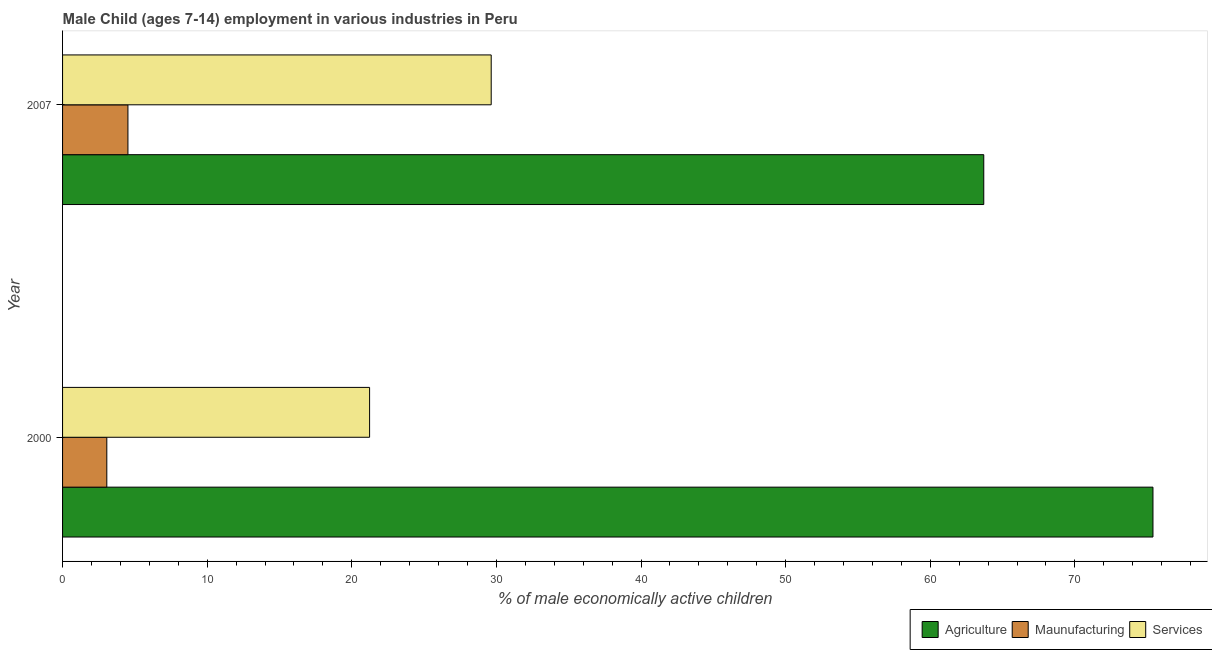How many different coloured bars are there?
Your response must be concise. 3. How many groups of bars are there?
Give a very brief answer. 2. Are the number of bars per tick equal to the number of legend labels?
Your answer should be compact. Yes. How many bars are there on the 2nd tick from the bottom?
Your response must be concise. 3. In how many cases, is the number of bars for a given year not equal to the number of legend labels?
Keep it short and to the point. 0. What is the percentage of economically active children in services in 2000?
Make the answer very short. 21.23. Across all years, what is the maximum percentage of economically active children in manufacturing?
Give a very brief answer. 4.52. Across all years, what is the minimum percentage of economically active children in services?
Offer a very short reply. 21.23. In which year was the percentage of economically active children in agriculture maximum?
Provide a short and direct response. 2000. What is the total percentage of economically active children in manufacturing in the graph?
Keep it short and to the point. 7.58. What is the difference between the percentage of economically active children in agriculture in 2000 and that in 2007?
Provide a short and direct response. 11.7. What is the difference between the percentage of economically active children in services in 2000 and the percentage of economically active children in agriculture in 2007?
Give a very brief answer. -42.47. What is the average percentage of economically active children in agriculture per year?
Offer a terse response. 69.55. In the year 2000, what is the difference between the percentage of economically active children in agriculture and percentage of economically active children in services?
Your response must be concise. 54.17. In how many years, is the percentage of economically active children in agriculture greater than 16 %?
Your response must be concise. 2. What is the ratio of the percentage of economically active children in agriculture in 2000 to that in 2007?
Keep it short and to the point. 1.18. Is the percentage of economically active children in services in 2000 less than that in 2007?
Provide a succinct answer. Yes. In how many years, is the percentage of economically active children in manufacturing greater than the average percentage of economically active children in manufacturing taken over all years?
Your answer should be very brief. 1. What does the 3rd bar from the top in 2000 represents?
Your answer should be compact. Agriculture. What does the 3rd bar from the bottom in 2007 represents?
Ensure brevity in your answer.  Services. Where does the legend appear in the graph?
Offer a very short reply. Bottom right. How are the legend labels stacked?
Offer a very short reply. Horizontal. What is the title of the graph?
Offer a very short reply. Male Child (ages 7-14) employment in various industries in Peru. What is the label or title of the X-axis?
Keep it short and to the point. % of male economically active children. What is the label or title of the Y-axis?
Your answer should be compact. Year. What is the % of male economically active children in Agriculture in 2000?
Your response must be concise. 75.4. What is the % of male economically active children of Maunufacturing in 2000?
Keep it short and to the point. 3.06. What is the % of male economically active children of Services in 2000?
Give a very brief answer. 21.23. What is the % of male economically active children of Agriculture in 2007?
Keep it short and to the point. 63.7. What is the % of male economically active children in Maunufacturing in 2007?
Offer a very short reply. 4.52. What is the % of male economically active children in Services in 2007?
Offer a very short reply. 29.64. Across all years, what is the maximum % of male economically active children in Agriculture?
Your answer should be very brief. 75.4. Across all years, what is the maximum % of male economically active children in Maunufacturing?
Provide a short and direct response. 4.52. Across all years, what is the maximum % of male economically active children of Services?
Offer a terse response. 29.64. Across all years, what is the minimum % of male economically active children in Agriculture?
Keep it short and to the point. 63.7. Across all years, what is the minimum % of male economically active children in Maunufacturing?
Keep it short and to the point. 3.06. Across all years, what is the minimum % of male economically active children of Services?
Your answer should be very brief. 21.23. What is the total % of male economically active children of Agriculture in the graph?
Offer a very short reply. 139.1. What is the total % of male economically active children of Maunufacturing in the graph?
Give a very brief answer. 7.58. What is the total % of male economically active children of Services in the graph?
Provide a short and direct response. 50.87. What is the difference between the % of male economically active children of Agriculture in 2000 and that in 2007?
Make the answer very short. 11.7. What is the difference between the % of male economically active children in Maunufacturing in 2000 and that in 2007?
Give a very brief answer. -1.46. What is the difference between the % of male economically active children in Services in 2000 and that in 2007?
Your answer should be compact. -8.41. What is the difference between the % of male economically active children in Agriculture in 2000 and the % of male economically active children in Maunufacturing in 2007?
Give a very brief answer. 70.88. What is the difference between the % of male economically active children in Agriculture in 2000 and the % of male economically active children in Services in 2007?
Offer a terse response. 45.76. What is the difference between the % of male economically active children in Maunufacturing in 2000 and the % of male economically active children in Services in 2007?
Provide a succinct answer. -26.58. What is the average % of male economically active children in Agriculture per year?
Provide a succinct answer. 69.55. What is the average % of male economically active children of Maunufacturing per year?
Your answer should be compact. 3.79. What is the average % of male economically active children in Services per year?
Your response must be concise. 25.43. In the year 2000, what is the difference between the % of male economically active children of Agriculture and % of male economically active children of Maunufacturing?
Your answer should be compact. 72.34. In the year 2000, what is the difference between the % of male economically active children in Agriculture and % of male economically active children in Services?
Your response must be concise. 54.17. In the year 2000, what is the difference between the % of male economically active children of Maunufacturing and % of male economically active children of Services?
Offer a very short reply. -18.17. In the year 2007, what is the difference between the % of male economically active children in Agriculture and % of male economically active children in Maunufacturing?
Give a very brief answer. 59.18. In the year 2007, what is the difference between the % of male economically active children in Agriculture and % of male economically active children in Services?
Offer a terse response. 34.06. In the year 2007, what is the difference between the % of male economically active children in Maunufacturing and % of male economically active children in Services?
Make the answer very short. -25.12. What is the ratio of the % of male economically active children in Agriculture in 2000 to that in 2007?
Your answer should be very brief. 1.18. What is the ratio of the % of male economically active children of Maunufacturing in 2000 to that in 2007?
Ensure brevity in your answer.  0.68. What is the ratio of the % of male economically active children in Services in 2000 to that in 2007?
Give a very brief answer. 0.72. What is the difference between the highest and the second highest % of male economically active children of Agriculture?
Keep it short and to the point. 11.7. What is the difference between the highest and the second highest % of male economically active children in Maunufacturing?
Provide a short and direct response. 1.46. What is the difference between the highest and the second highest % of male economically active children of Services?
Give a very brief answer. 8.41. What is the difference between the highest and the lowest % of male economically active children of Agriculture?
Provide a succinct answer. 11.7. What is the difference between the highest and the lowest % of male economically active children in Maunufacturing?
Ensure brevity in your answer.  1.46. What is the difference between the highest and the lowest % of male economically active children in Services?
Keep it short and to the point. 8.41. 